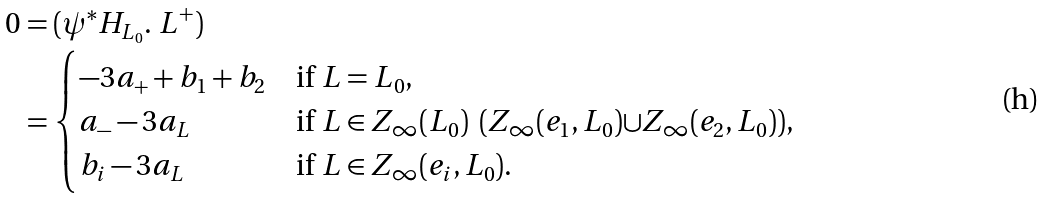<formula> <loc_0><loc_0><loc_500><loc_500>0 & = ( \psi ^ { * } H _ { L _ { 0 } } . \ L ^ { + } ) \\ & = \begin{cases} - 3 a _ { + } + b _ { 1 } + b _ { 2 } & \text {if $L=L_{0}$} , \\ a _ { - } - 3 a _ { L } & \text {if ${L}\in{Z_{\infty}(L_{0})}\ \left(Z_{\infty}(e_{1},L_{0}){\cup}Z_{\infty}(e_{2},L_{0}) \right)$} , \\ b _ { i } - 3 a _ { L } & \text {if ${L}\in{Z_{\infty}(e_{i},L_{0})}$} . \end{cases}</formula> 